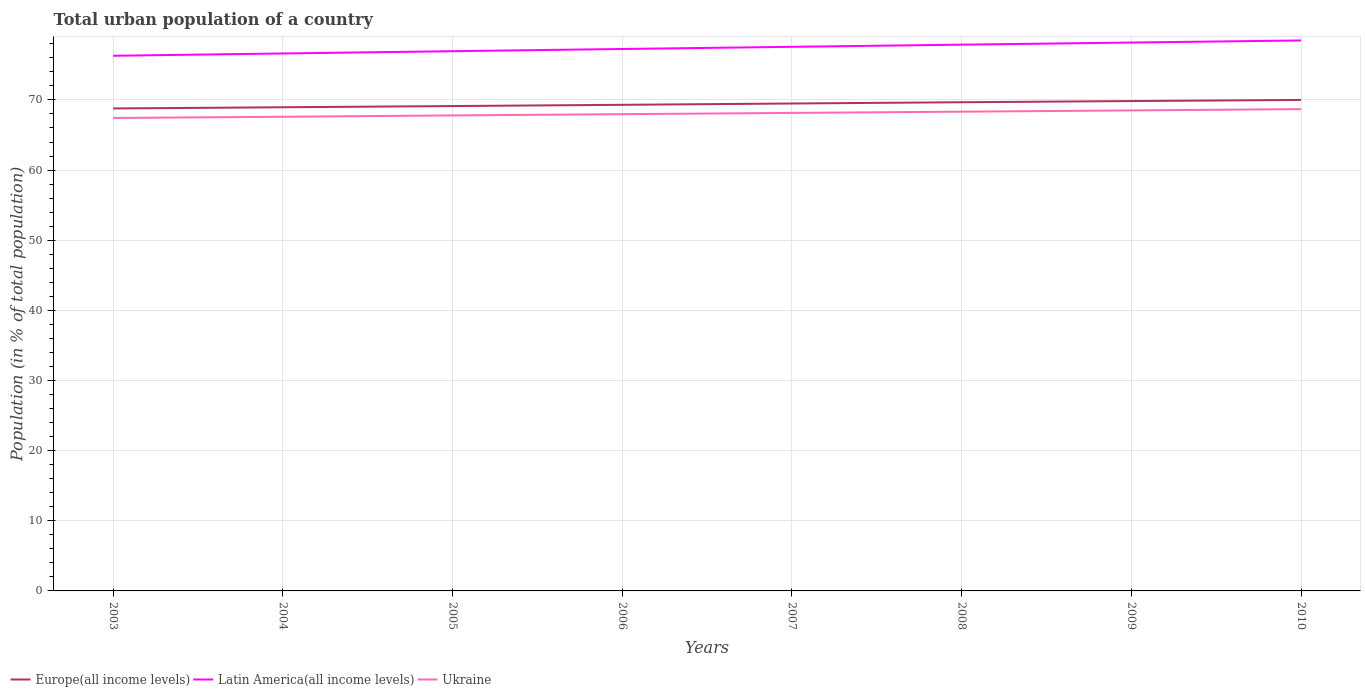Does the line corresponding to Ukraine intersect with the line corresponding to Latin America(all income levels)?
Keep it short and to the point. No. Across all years, what is the maximum urban population in Latin America(all income levels)?
Offer a terse response. 76.3. What is the total urban population in Ukraine in the graph?
Offer a terse response. -0.36. What is the difference between the highest and the second highest urban population in Ukraine?
Give a very brief answer. 1.26. What is the difference between the highest and the lowest urban population in Ukraine?
Your answer should be compact. 4. How many lines are there?
Your answer should be compact. 3. What is the difference between two consecutive major ticks on the Y-axis?
Ensure brevity in your answer.  10. Are the values on the major ticks of Y-axis written in scientific E-notation?
Your response must be concise. No. Does the graph contain any zero values?
Offer a very short reply. No. How are the legend labels stacked?
Your response must be concise. Horizontal. What is the title of the graph?
Make the answer very short. Total urban population of a country. Does "Virgin Islands" appear as one of the legend labels in the graph?
Give a very brief answer. No. What is the label or title of the X-axis?
Offer a terse response. Years. What is the label or title of the Y-axis?
Offer a very short reply. Population (in % of total population). What is the Population (in % of total population) of Europe(all income levels) in 2003?
Your response must be concise. 68.78. What is the Population (in % of total population) in Latin America(all income levels) in 2003?
Keep it short and to the point. 76.3. What is the Population (in % of total population) in Ukraine in 2003?
Make the answer very short. 67.43. What is the Population (in % of total population) in Europe(all income levels) in 2004?
Offer a very short reply. 68.95. What is the Population (in % of total population) of Latin America(all income levels) in 2004?
Provide a succinct answer. 76.62. What is the Population (in % of total population) of Ukraine in 2004?
Your answer should be very brief. 67.6. What is the Population (in % of total population) in Europe(all income levels) in 2005?
Offer a very short reply. 69.12. What is the Population (in % of total population) of Latin America(all income levels) in 2005?
Provide a short and direct response. 76.94. What is the Population (in % of total population) of Ukraine in 2005?
Provide a succinct answer. 67.79. What is the Population (in % of total population) in Europe(all income levels) in 2006?
Give a very brief answer. 69.3. What is the Population (in % of total population) in Latin America(all income levels) in 2006?
Offer a terse response. 77.26. What is the Population (in % of total population) in Ukraine in 2006?
Your response must be concise. 67.97. What is the Population (in % of total population) of Europe(all income levels) in 2007?
Provide a short and direct response. 69.49. What is the Population (in % of total population) in Latin America(all income levels) in 2007?
Offer a terse response. 77.57. What is the Population (in % of total population) in Ukraine in 2007?
Offer a terse response. 68.15. What is the Population (in % of total population) in Europe(all income levels) in 2008?
Ensure brevity in your answer.  69.67. What is the Population (in % of total population) in Latin America(all income levels) in 2008?
Provide a succinct answer. 77.88. What is the Population (in % of total population) in Ukraine in 2008?
Provide a succinct answer. 68.33. What is the Population (in % of total population) of Europe(all income levels) in 2009?
Your answer should be compact. 69.84. What is the Population (in % of total population) of Latin America(all income levels) in 2009?
Offer a very short reply. 78.18. What is the Population (in % of total population) in Ukraine in 2009?
Ensure brevity in your answer.  68.5. What is the Population (in % of total population) of Europe(all income levels) in 2010?
Give a very brief answer. 70. What is the Population (in % of total population) of Latin America(all income levels) in 2010?
Ensure brevity in your answer.  78.48. What is the Population (in % of total population) of Ukraine in 2010?
Your answer should be very brief. 68.69. Across all years, what is the maximum Population (in % of total population) of Europe(all income levels)?
Offer a terse response. 70. Across all years, what is the maximum Population (in % of total population) of Latin America(all income levels)?
Make the answer very short. 78.48. Across all years, what is the maximum Population (in % of total population) of Ukraine?
Ensure brevity in your answer.  68.69. Across all years, what is the minimum Population (in % of total population) of Europe(all income levels)?
Keep it short and to the point. 68.78. Across all years, what is the minimum Population (in % of total population) of Latin America(all income levels)?
Keep it short and to the point. 76.3. Across all years, what is the minimum Population (in % of total population) in Ukraine?
Offer a terse response. 67.43. What is the total Population (in % of total population) in Europe(all income levels) in the graph?
Ensure brevity in your answer.  555.16. What is the total Population (in % of total population) in Latin America(all income levels) in the graph?
Your answer should be very brief. 619.23. What is the total Population (in % of total population) in Ukraine in the graph?
Ensure brevity in your answer.  544.44. What is the difference between the Population (in % of total population) of Europe(all income levels) in 2003 and that in 2004?
Make the answer very short. -0.17. What is the difference between the Population (in % of total population) in Latin America(all income levels) in 2003 and that in 2004?
Provide a succinct answer. -0.33. What is the difference between the Population (in % of total population) in Ukraine in 2003 and that in 2004?
Offer a terse response. -0.17. What is the difference between the Population (in % of total population) of Europe(all income levels) in 2003 and that in 2005?
Offer a terse response. -0.34. What is the difference between the Population (in % of total population) of Latin America(all income levels) in 2003 and that in 2005?
Provide a succinct answer. -0.65. What is the difference between the Population (in % of total population) in Ukraine in 2003 and that in 2005?
Your response must be concise. -0.36. What is the difference between the Population (in % of total population) in Europe(all income levels) in 2003 and that in 2006?
Give a very brief answer. -0.52. What is the difference between the Population (in % of total population) of Latin America(all income levels) in 2003 and that in 2006?
Offer a very short reply. -0.96. What is the difference between the Population (in % of total population) of Ukraine in 2003 and that in 2006?
Give a very brief answer. -0.54. What is the difference between the Population (in % of total population) in Europe(all income levels) in 2003 and that in 2007?
Offer a very short reply. -0.71. What is the difference between the Population (in % of total population) in Latin America(all income levels) in 2003 and that in 2007?
Ensure brevity in your answer.  -1.28. What is the difference between the Population (in % of total population) in Ukraine in 2003 and that in 2007?
Offer a very short reply. -0.72. What is the difference between the Population (in % of total population) in Europe(all income levels) in 2003 and that in 2008?
Keep it short and to the point. -0.89. What is the difference between the Population (in % of total population) in Latin America(all income levels) in 2003 and that in 2008?
Offer a terse response. -1.58. What is the difference between the Population (in % of total population) of Ukraine in 2003 and that in 2008?
Provide a short and direct response. -0.9. What is the difference between the Population (in % of total population) in Europe(all income levels) in 2003 and that in 2009?
Offer a very short reply. -1.05. What is the difference between the Population (in % of total population) in Latin America(all income levels) in 2003 and that in 2009?
Offer a terse response. -1.88. What is the difference between the Population (in % of total population) of Ukraine in 2003 and that in 2009?
Give a very brief answer. -1.07. What is the difference between the Population (in % of total population) in Europe(all income levels) in 2003 and that in 2010?
Offer a very short reply. -1.21. What is the difference between the Population (in % of total population) of Latin America(all income levels) in 2003 and that in 2010?
Offer a very short reply. -2.18. What is the difference between the Population (in % of total population) of Ukraine in 2003 and that in 2010?
Make the answer very short. -1.26. What is the difference between the Population (in % of total population) in Europe(all income levels) in 2004 and that in 2005?
Your response must be concise. -0.17. What is the difference between the Population (in % of total population) of Latin America(all income levels) in 2004 and that in 2005?
Provide a succinct answer. -0.32. What is the difference between the Population (in % of total population) in Ukraine in 2004 and that in 2005?
Provide a short and direct response. -0.19. What is the difference between the Population (in % of total population) of Europe(all income levels) in 2004 and that in 2006?
Make the answer very short. -0.35. What is the difference between the Population (in % of total population) of Latin America(all income levels) in 2004 and that in 2006?
Provide a short and direct response. -0.64. What is the difference between the Population (in % of total population) in Ukraine in 2004 and that in 2006?
Offer a very short reply. -0.37. What is the difference between the Population (in % of total population) in Europe(all income levels) in 2004 and that in 2007?
Provide a succinct answer. -0.54. What is the difference between the Population (in % of total population) in Latin America(all income levels) in 2004 and that in 2007?
Your answer should be compact. -0.95. What is the difference between the Population (in % of total population) of Ukraine in 2004 and that in 2007?
Make the answer very short. -0.55. What is the difference between the Population (in % of total population) in Europe(all income levels) in 2004 and that in 2008?
Make the answer very short. -0.72. What is the difference between the Population (in % of total population) in Latin America(all income levels) in 2004 and that in 2008?
Your answer should be very brief. -1.26. What is the difference between the Population (in % of total population) of Ukraine in 2004 and that in 2008?
Ensure brevity in your answer.  -0.73. What is the difference between the Population (in % of total population) of Europe(all income levels) in 2004 and that in 2009?
Keep it short and to the point. -0.89. What is the difference between the Population (in % of total population) of Latin America(all income levels) in 2004 and that in 2009?
Provide a short and direct response. -1.56. What is the difference between the Population (in % of total population) of Ukraine in 2004 and that in 2009?
Offer a terse response. -0.91. What is the difference between the Population (in % of total population) in Europe(all income levels) in 2004 and that in 2010?
Provide a short and direct response. -1.04. What is the difference between the Population (in % of total population) of Latin America(all income levels) in 2004 and that in 2010?
Keep it short and to the point. -1.85. What is the difference between the Population (in % of total population) in Ukraine in 2004 and that in 2010?
Offer a terse response. -1.09. What is the difference between the Population (in % of total population) of Europe(all income levels) in 2005 and that in 2006?
Make the answer very short. -0.18. What is the difference between the Population (in % of total population) in Latin America(all income levels) in 2005 and that in 2006?
Your answer should be compact. -0.32. What is the difference between the Population (in % of total population) in Ukraine in 2005 and that in 2006?
Offer a very short reply. -0.18. What is the difference between the Population (in % of total population) of Europe(all income levels) in 2005 and that in 2007?
Keep it short and to the point. -0.36. What is the difference between the Population (in % of total population) in Latin America(all income levels) in 2005 and that in 2007?
Your response must be concise. -0.63. What is the difference between the Population (in % of total population) in Ukraine in 2005 and that in 2007?
Your answer should be very brief. -0.36. What is the difference between the Population (in % of total population) of Europe(all income levels) in 2005 and that in 2008?
Provide a short and direct response. -0.55. What is the difference between the Population (in % of total population) in Latin America(all income levels) in 2005 and that in 2008?
Ensure brevity in your answer.  -0.93. What is the difference between the Population (in % of total population) in Ukraine in 2005 and that in 2008?
Ensure brevity in your answer.  -0.54. What is the difference between the Population (in % of total population) in Europe(all income levels) in 2005 and that in 2009?
Give a very brief answer. -0.71. What is the difference between the Population (in % of total population) of Latin America(all income levels) in 2005 and that in 2009?
Offer a terse response. -1.24. What is the difference between the Population (in % of total population) in Ukraine in 2005 and that in 2009?
Provide a succinct answer. -0.71. What is the difference between the Population (in % of total population) of Europe(all income levels) in 2005 and that in 2010?
Your response must be concise. -0.87. What is the difference between the Population (in % of total population) of Latin America(all income levels) in 2005 and that in 2010?
Keep it short and to the point. -1.53. What is the difference between the Population (in % of total population) in Ukraine in 2005 and that in 2010?
Offer a very short reply. -0.9. What is the difference between the Population (in % of total population) in Europe(all income levels) in 2006 and that in 2007?
Keep it short and to the point. -0.19. What is the difference between the Population (in % of total population) in Latin America(all income levels) in 2006 and that in 2007?
Offer a very short reply. -0.31. What is the difference between the Population (in % of total population) of Ukraine in 2006 and that in 2007?
Keep it short and to the point. -0.18. What is the difference between the Population (in % of total population) in Europe(all income levels) in 2006 and that in 2008?
Offer a terse response. -0.37. What is the difference between the Population (in % of total population) of Latin America(all income levels) in 2006 and that in 2008?
Provide a succinct answer. -0.62. What is the difference between the Population (in % of total population) in Ukraine in 2006 and that in 2008?
Your response must be concise. -0.36. What is the difference between the Population (in % of total population) in Europe(all income levels) in 2006 and that in 2009?
Ensure brevity in your answer.  -0.53. What is the difference between the Population (in % of total population) in Latin America(all income levels) in 2006 and that in 2009?
Provide a short and direct response. -0.92. What is the difference between the Population (in % of total population) in Ukraine in 2006 and that in 2009?
Offer a terse response. -0.53. What is the difference between the Population (in % of total population) of Europe(all income levels) in 2006 and that in 2010?
Keep it short and to the point. -0.69. What is the difference between the Population (in % of total population) in Latin America(all income levels) in 2006 and that in 2010?
Ensure brevity in your answer.  -1.22. What is the difference between the Population (in % of total population) in Ukraine in 2006 and that in 2010?
Provide a short and direct response. -0.72. What is the difference between the Population (in % of total population) of Europe(all income levels) in 2007 and that in 2008?
Provide a short and direct response. -0.18. What is the difference between the Population (in % of total population) of Latin America(all income levels) in 2007 and that in 2008?
Make the answer very short. -0.31. What is the difference between the Population (in % of total population) of Ukraine in 2007 and that in 2008?
Provide a short and direct response. -0.18. What is the difference between the Population (in % of total population) of Europe(all income levels) in 2007 and that in 2009?
Provide a short and direct response. -0.35. What is the difference between the Population (in % of total population) in Latin America(all income levels) in 2007 and that in 2009?
Your response must be concise. -0.61. What is the difference between the Population (in % of total population) of Ukraine in 2007 and that in 2009?
Offer a very short reply. -0.35. What is the difference between the Population (in % of total population) of Europe(all income levels) in 2007 and that in 2010?
Offer a very short reply. -0.51. What is the difference between the Population (in % of total population) in Latin America(all income levels) in 2007 and that in 2010?
Your response must be concise. -0.91. What is the difference between the Population (in % of total population) of Ukraine in 2007 and that in 2010?
Provide a short and direct response. -0.54. What is the difference between the Population (in % of total population) of Europe(all income levels) in 2008 and that in 2009?
Keep it short and to the point. -0.17. What is the difference between the Population (in % of total population) of Latin America(all income levels) in 2008 and that in 2009?
Keep it short and to the point. -0.3. What is the difference between the Population (in % of total population) in Ukraine in 2008 and that in 2009?
Your response must be concise. -0.18. What is the difference between the Population (in % of total population) in Europe(all income levels) in 2008 and that in 2010?
Offer a terse response. -0.33. What is the difference between the Population (in % of total population) of Latin America(all income levels) in 2008 and that in 2010?
Your answer should be very brief. -0.6. What is the difference between the Population (in % of total population) in Ukraine in 2008 and that in 2010?
Give a very brief answer. -0.36. What is the difference between the Population (in % of total population) of Europe(all income levels) in 2009 and that in 2010?
Ensure brevity in your answer.  -0.16. What is the difference between the Population (in % of total population) of Latin America(all income levels) in 2009 and that in 2010?
Give a very brief answer. -0.3. What is the difference between the Population (in % of total population) of Ukraine in 2009 and that in 2010?
Your answer should be compact. -0.18. What is the difference between the Population (in % of total population) of Europe(all income levels) in 2003 and the Population (in % of total population) of Latin America(all income levels) in 2004?
Offer a terse response. -7.84. What is the difference between the Population (in % of total population) in Europe(all income levels) in 2003 and the Population (in % of total population) in Ukraine in 2004?
Provide a short and direct response. 1.19. What is the difference between the Population (in % of total population) in Latin America(all income levels) in 2003 and the Population (in % of total population) in Ukraine in 2004?
Provide a succinct answer. 8.7. What is the difference between the Population (in % of total population) in Europe(all income levels) in 2003 and the Population (in % of total population) in Latin America(all income levels) in 2005?
Offer a terse response. -8.16. What is the difference between the Population (in % of total population) of Latin America(all income levels) in 2003 and the Population (in % of total population) of Ukraine in 2005?
Give a very brief answer. 8.51. What is the difference between the Population (in % of total population) of Europe(all income levels) in 2003 and the Population (in % of total population) of Latin America(all income levels) in 2006?
Provide a succinct answer. -8.48. What is the difference between the Population (in % of total population) in Europe(all income levels) in 2003 and the Population (in % of total population) in Ukraine in 2006?
Ensure brevity in your answer.  0.81. What is the difference between the Population (in % of total population) in Latin America(all income levels) in 2003 and the Population (in % of total population) in Ukraine in 2006?
Ensure brevity in your answer.  8.33. What is the difference between the Population (in % of total population) of Europe(all income levels) in 2003 and the Population (in % of total population) of Latin America(all income levels) in 2007?
Make the answer very short. -8.79. What is the difference between the Population (in % of total population) of Europe(all income levels) in 2003 and the Population (in % of total population) of Ukraine in 2007?
Your answer should be compact. 0.64. What is the difference between the Population (in % of total population) of Latin America(all income levels) in 2003 and the Population (in % of total population) of Ukraine in 2007?
Ensure brevity in your answer.  8.15. What is the difference between the Population (in % of total population) in Europe(all income levels) in 2003 and the Population (in % of total population) in Latin America(all income levels) in 2008?
Your answer should be very brief. -9.1. What is the difference between the Population (in % of total population) of Europe(all income levels) in 2003 and the Population (in % of total population) of Ukraine in 2008?
Your answer should be very brief. 0.46. What is the difference between the Population (in % of total population) of Latin America(all income levels) in 2003 and the Population (in % of total population) of Ukraine in 2008?
Provide a succinct answer. 7.97. What is the difference between the Population (in % of total population) of Europe(all income levels) in 2003 and the Population (in % of total population) of Latin America(all income levels) in 2009?
Provide a succinct answer. -9.4. What is the difference between the Population (in % of total population) in Europe(all income levels) in 2003 and the Population (in % of total population) in Ukraine in 2009?
Provide a succinct answer. 0.28. What is the difference between the Population (in % of total population) in Latin America(all income levels) in 2003 and the Population (in % of total population) in Ukraine in 2009?
Your answer should be compact. 7.79. What is the difference between the Population (in % of total population) of Europe(all income levels) in 2003 and the Population (in % of total population) of Latin America(all income levels) in 2010?
Provide a succinct answer. -9.7. What is the difference between the Population (in % of total population) in Europe(all income levels) in 2003 and the Population (in % of total population) in Ukraine in 2010?
Your response must be concise. 0.1. What is the difference between the Population (in % of total population) of Latin America(all income levels) in 2003 and the Population (in % of total population) of Ukraine in 2010?
Give a very brief answer. 7.61. What is the difference between the Population (in % of total population) of Europe(all income levels) in 2004 and the Population (in % of total population) of Latin America(all income levels) in 2005?
Your answer should be compact. -7.99. What is the difference between the Population (in % of total population) of Europe(all income levels) in 2004 and the Population (in % of total population) of Ukraine in 2005?
Provide a succinct answer. 1.16. What is the difference between the Population (in % of total population) of Latin America(all income levels) in 2004 and the Population (in % of total population) of Ukraine in 2005?
Your answer should be very brief. 8.83. What is the difference between the Population (in % of total population) of Europe(all income levels) in 2004 and the Population (in % of total population) of Latin America(all income levels) in 2006?
Provide a succinct answer. -8.31. What is the difference between the Population (in % of total population) in Europe(all income levels) in 2004 and the Population (in % of total population) in Ukraine in 2006?
Make the answer very short. 0.98. What is the difference between the Population (in % of total population) in Latin America(all income levels) in 2004 and the Population (in % of total population) in Ukraine in 2006?
Your answer should be compact. 8.65. What is the difference between the Population (in % of total population) in Europe(all income levels) in 2004 and the Population (in % of total population) in Latin America(all income levels) in 2007?
Provide a short and direct response. -8.62. What is the difference between the Population (in % of total population) of Europe(all income levels) in 2004 and the Population (in % of total population) of Ukraine in 2007?
Make the answer very short. 0.81. What is the difference between the Population (in % of total population) of Latin America(all income levels) in 2004 and the Population (in % of total population) of Ukraine in 2007?
Make the answer very short. 8.48. What is the difference between the Population (in % of total population) in Europe(all income levels) in 2004 and the Population (in % of total population) in Latin America(all income levels) in 2008?
Make the answer very short. -8.93. What is the difference between the Population (in % of total population) of Europe(all income levels) in 2004 and the Population (in % of total population) of Ukraine in 2008?
Your answer should be very brief. 0.63. What is the difference between the Population (in % of total population) in Latin America(all income levels) in 2004 and the Population (in % of total population) in Ukraine in 2008?
Your response must be concise. 8.3. What is the difference between the Population (in % of total population) in Europe(all income levels) in 2004 and the Population (in % of total population) in Latin America(all income levels) in 2009?
Give a very brief answer. -9.23. What is the difference between the Population (in % of total population) of Europe(all income levels) in 2004 and the Population (in % of total population) of Ukraine in 2009?
Your answer should be compact. 0.45. What is the difference between the Population (in % of total population) of Latin America(all income levels) in 2004 and the Population (in % of total population) of Ukraine in 2009?
Provide a short and direct response. 8.12. What is the difference between the Population (in % of total population) of Europe(all income levels) in 2004 and the Population (in % of total population) of Latin America(all income levels) in 2010?
Make the answer very short. -9.53. What is the difference between the Population (in % of total population) in Europe(all income levels) in 2004 and the Population (in % of total population) in Ukraine in 2010?
Make the answer very short. 0.27. What is the difference between the Population (in % of total population) of Latin America(all income levels) in 2004 and the Population (in % of total population) of Ukraine in 2010?
Your answer should be very brief. 7.94. What is the difference between the Population (in % of total population) in Europe(all income levels) in 2005 and the Population (in % of total population) in Latin America(all income levels) in 2006?
Make the answer very short. -8.14. What is the difference between the Population (in % of total population) of Europe(all income levels) in 2005 and the Population (in % of total population) of Ukraine in 2006?
Provide a short and direct response. 1.16. What is the difference between the Population (in % of total population) of Latin America(all income levels) in 2005 and the Population (in % of total population) of Ukraine in 2006?
Make the answer very short. 8.97. What is the difference between the Population (in % of total population) of Europe(all income levels) in 2005 and the Population (in % of total population) of Latin America(all income levels) in 2007?
Ensure brevity in your answer.  -8.45. What is the difference between the Population (in % of total population) in Europe(all income levels) in 2005 and the Population (in % of total population) in Ukraine in 2007?
Your answer should be compact. 0.98. What is the difference between the Population (in % of total population) of Latin America(all income levels) in 2005 and the Population (in % of total population) of Ukraine in 2007?
Offer a very short reply. 8.8. What is the difference between the Population (in % of total population) of Europe(all income levels) in 2005 and the Population (in % of total population) of Latin America(all income levels) in 2008?
Your response must be concise. -8.75. What is the difference between the Population (in % of total population) of Europe(all income levels) in 2005 and the Population (in % of total population) of Ukraine in 2008?
Keep it short and to the point. 0.8. What is the difference between the Population (in % of total population) of Latin America(all income levels) in 2005 and the Population (in % of total population) of Ukraine in 2008?
Provide a short and direct response. 8.62. What is the difference between the Population (in % of total population) in Europe(all income levels) in 2005 and the Population (in % of total population) in Latin America(all income levels) in 2009?
Provide a short and direct response. -9.06. What is the difference between the Population (in % of total population) of Europe(all income levels) in 2005 and the Population (in % of total population) of Ukraine in 2009?
Give a very brief answer. 0.62. What is the difference between the Population (in % of total population) in Latin America(all income levels) in 2005 and the Population (in % of total population) in Ukraine in 2009?
Your answer should be compact. 8.44. What is the difference between the Population (in % of total population) of Europe(all income levels) in 2005 and the Population (in % of total population) of Latin America(all income levels) in 2010?
Provide a succinct answer. -9.35. What is the difference between the Population (in % of total population) of Europe(all income levels) in 2005 and the Population (in % of total population) of Ukraine in 2010?
Provide a succinct answer. 0.44. What is the difference between the Population (in % of total population) in Latin America(all income levels) in 2005 and the Population (in % of total population) in Ukraine in 2010?
Your response must be concise. 8.26. What is the difference between the Population (in % of total population) of Europe(all income levels) in 2006 and the Population (in % of total population) of Latin America(all income levels) in 2007?
Provide a short and direct response. -8.27. What is the difference between the Population (in % of total population) of Europe(all income levels) in 2006 and the Population (in % of total population) of Ukraine in 2007?
Your response must be concise. 1.16. What is the difference between the Population (in % of total population) in Latin America(all income levels) in 2006 and the Population (in % of total population) in Ukraine in 2007?
Your answer should be compact. 9.11. What is the difference between the Population (in % of total population) of Europe(all income levels) in 2006 and the Population (in % of total population) of Latin America(all income levels) in 2008?
Your answer should be very brief. -8.58. What is the difference between the Population (in % of total population) in Europe(all income levels) in 2006 and the Population (in % of total population) in Ukraine in 2008?
Keep it short and to the point. 0.98. What is the difference between the Population (in % of total population) of Latin America(all income levels) in 2006 and the Population (in % of total population) of Ukraine in 2008?
Make the answer very short. 8.94. What is the difference between the Population (in % of total population) in Europe(all income levels) in 2006 and the Population (in % of total population) in Latin America(all income levels) in 2009?
Your response must be concise. -8.88. What is the difference between the Population (in % of total population) in Europe(all income levels) in 2006 and the Population (in % of total population) in Ukraine in 2009?
Ensure brevity in your answer.  0.8. What is the difference between the Population (in % of total population) of Latin America(all income levels) in 2006 and the Population (in % of total population) of Ukraine in 2009?
Give a very brief answer. 8.76. What is the difference between the Population (in % of total population) in Europe(all income levels) in 2006 and the Population (in % of total population) in Latin America(all income levels) in 2010?
Your answer should be very brief. -9.17. What is the difference between the Population (in % of total population) in Europe(all income levels) in 2006 and the Population (in % of total population) in Ukraine in 2010?
Offer a very short reply. 0.62. What is the difference between the Population (in % of total population) in Latin America(all income levels) in 2006 and the Population (in % of total population) in Ukraine in 2010?
Make the answer very short. 8.57. What is the difference between the Population (in % of total population) of Europe(all income levels) in 2007 and the Population (in % of total population) of Latin America(all income levels) in 2008?
Give a very brief answer. -8.39. What is the difference between the Population (in % of total population) of Europe(all income levels) in 2007 and the Population (in % of total population) of Ukraine in 2008?
Your answer should be compact. 1.16. What is the difference between the Population (in % of total population) in Latin America(all income levels) in 2007 and the Population (in % of total population) in Ukraine in 2008?
Make the answer very short. 9.25. What is the difference between the Population (in % of total population) in Europe(all income levels) in 2007 and the Population (in % of total population) in Latin America(all income levels) in 2009?
Make the answer very short. -8.69. What is the difference between the Population (in % of total population) of Europe(all income levels) in 2007 and the Population (in % of total population) of Ukraine in 2009?
Offer a terse response. 0.99. What is the difference between the Population (in % of total population) of Latin America(all income levels) in 2007 and the Population (in % of total population) of Ukraine in 2009?
Give a very brief answer. 9.07. What is the difference between the Population (in % of total population) of Europe(all income levels) in 2007 and the Population (in % of total population) of Latin America(all income levels) in 2010?
Keep it short and to the point. -8.99. What is the difference between the Population (in % of total population) in Europe(all income levels) in 2007 and the Population (in % of total population) in Ukraine in 2010?
Keep it short and to the point. 0.8. What is the difference between the Population (in % of total population) of Latin America(all income levels) in 2007 and the Population (in % of total population) of Ukraine in 2010?
Offer a terse response. 8.89. What is the difference between the Population (in % of total population) of Europe(all income levels) in 2008 and the Population (in % of total population) of Latin America(all income levels) in 2009?
Make the answer very short. -8.51. What is the difference between the Population (in % of total population) of Europe(all income levels) in 2008 and the Population (in % of total population) of Ukraine in 2009?
Provide a succinct answer. 1.17. What is the difference between the Population (in % of total population) of Latin America(all income levels) in 2008 and the Population (in % of total population) of Ukraine in 2009?
Provide a short and direct response. 9.38. What is the difference between the Population (in % of total population) in Europe(all income levels) in 2008 and the Population (in % of total population) in Latin America(all income levels) in 2010?
Your response must be concise. -8.81. What is the difference between the Population (in % of total population) of Europe(all income levels) in 2008 and the Population (in % of total population) of Ukraine in 2010?
Your response must be concise. 0.98. What is the difference between the Population (in % of total population) in Latin America(all income levels) in 2008 and the Population (in % of total population) in Ukraine in 2010?
Offer a very short reply. 9.19. What is the difference between the Population (in % of total population) in Europe(all income levels) in 2009 and the Population (in % of total population) in Latin America(all income levels) in 2010?
Ensure brevity in your answer.  -8.64. What is the difference between the Population (in % of total population) of Europe(all income levels) in 2009 and the Population (in % of total population) of Ukraine in 2010?
Keep it short and to the point. 1.15. What is the difference between the Population (in % of total population) of Latin America(all income levels) in 2009 and the Population (in % of total population) of Ukraine in 2010?
Your response must be concise. 9.49. What is the average Population (in % of total population) of Europe(all income levels) per year?
Make the answer very short. 69.39. What is the average Population (in % of total population) of Latin America(all income levels) per year?
Keep it short and to the point. 77.4. What is the average Population (in % of total population) in Ukraine per year?
Provide a succinct answer. 68.06. In the year 2003, what is the difference between the Population (in % of total population) of Europe(all income levels) and Population (in % of total population) of Latin America(all income levels)?
Provide a succinct answer. -7.51. In the year 2003, what is the difference between the Population (in % of total population) of Europe(all income levels) and Population (in % of total population) of Ukraine?
Make the answer very short. 1.36. In the year 2003, what is the difference between the Population (in % of total population) of Latin America(all income levels) and Population (in % of total population) of Ukraine?
Your response must be concise. 8.87. In the year 2004, what is the difference between the Population (in % of total population) of Europe(all income levels) and Population (in % of total population) of Latin America(all income levels)?
Make the answer very short. -7.67. In the year 2004, what is the difference between the Population (in % of total population) in Europe(all income levels) and Population (in % of total population) in Ukraine?
Provide a short and direct response. 1.36. In the year 2004, what is the difference between the Population (in % of total population) of Latin America(all income levels) and Population (in % of total population) of Ukraine?
Ensure brevity in your answer.  9.03. In the year 2005, what is the difference between the Population (in % of total population) in Europe(all income levels) and Population (in % of total population) in Latin America(all income levels)?
Your answer should be very brief. -7.82. In the year 2005, what is the difference between the Population (in % of total population) in Europe(all income levels) and Population (in % of total population) in Ukraine?
Provide a succinct answer. 1.33. In the year 2005, what is the difference between the Population (in % of total population) in Latin America(all income levels) and Population (in % of total population) in Ukraine?
Offer a very short reply. 9.15. In the year 2006, what is the difference between the Population (in % of total population) of Europe(all income levels) and Population (in % of total population) of Latin America(all income levels)?
Your answer should be compact. -7.96. In the year 2006, what is the difference between the Population (in % of total population) of Europe(all income levels) and Population (in % of total population) of Ukraine?
Provide a short and direct response. 1.33. In the year 2006, what is the difference between the Population (in % of total population) in Latin America(all income levels) and Population (in % of total population) in Ukraine?
Your answer should be compact. 9.29. In the year 2007, what is the difference between the Population (in % of total population) in Europe(all income levels) and Population (in % of total population) in Latin America(all income levels)?
Offer a very short reply. -8.08. In the year 2007, what is the difference between the Population (in % of total population) in Europe(all income levels) and Population (in % of total population) in Ukraine?
Ensure brevity in your answer.  1.34. In the year 2007, what is the difference between the Population (in % of total population) of Latin America(all income levels) and Population (in % of total population) of Ukraine?
Give a very brief answer. 9.42. In the year 2008, what is the difference between the Population (in % of total population) in Europe(all income levels) and Population (in % of total population) in Latin America(all income levels)?
Offer a terse response. -8.21. In the year 2008, what is the difference between the Population (in % of total population) of Europe(all income levels) and Population (in % of total population) of Ukraine?
Provide a succinct answer. 1.35. In the year 2008, what is the difference between the Population (in % of total population) of Latin America(all income levels) and Population (in % of total population) of Ukraine?
Provide a short and direct response. 9.55. In the year 2009, what is the difference between the Population (in % of total population) in Europe(all income levels) and Population (in % of total population) in Latin America(all income levels)?
Provide a succinct answer. -8.34. In the year 2009, what is the difference between the Population (in % of total population) in Europe(all income levels) and Population (in % of total population) in Ukraine?
Give a very brief answer. 1.34. In the year 2009, what is the difference between the Population (in % of total population) in Latin America(all income levels) and Population (in % of total population) in Ukraine?
Make the answer very short. 9.68. In the year 2010, what is the difference between the Population (in % of total population) in Europe(all income levels) and Population (in % of total population) in Latin America(all income levels)?
Make the answer very short. -8.48. In the year 2010, what is the difference between the Population (in % of total population) of Europe(all income levels) and Population (in % of total population) of Ukraine?
Provide a succinct answer. 1.31. In the year 2010, what is the difference between the Population (in % of total population) in Latin America(all income levels) and Population (in % of total population) in Ukraine?
Keep it short and to the point. 9.79. What is the ratio of the Population (in % of total population) in Europe(all income levels) in 2003 to that in 2004?
Offer a terse response. 1. What is the ratio of the Population (in % of total population) in Latin America(all income levels) in 2003 to that in 2004?
Keep it short and to the point. 1. What is the ratio of the Population (in % of total population) in Europe(all income levels) in 2003 to that in 2005?
Offer a very short reply. 1. What is the ratio of the Population (in % of total population) of Latin America(all income levels) in 2003 to that in 2005?
Offer a terse response. 0.99. What is the ratio of the Population (in % of total population) of Europe(all income levels) in 2003 to that in 2006?
Your response must be concise. 0.99. What is the ratio of the Population (in % of total population) in Latin America(all income levels) in 2003 to that in 2006?
Provide a short and direct response. 0.99. What is the ratio of the Population (in % of total population) in Europe(all income levels) in 2003 to that in 2007?
Offer a terse response. 0.99. What is the ratio of the Population (in % of total population) in Latin America(all income levels) in 2003 to that in 2007?
Give a very brief answer. 0.98. What is the ratio of the Population (in % of total population) in Ukraine in 2003 to that in 2007?
Your answer should be compact. 0.99. What is the ratio of the Population (in % of total population) in Europe(all income levels) in 2003 to that in 2008?
Make the answer very short. 0.99. What is the ratio of the Population (in % of total population) in Latin America(all income levels) in 2003 to that in 2008?
Give a very brief answer. 0.98. What is the ratio of the Population (in % of total population) of Ukraine in 2003 to that in 2008?
Your answer should be very brief. 0.99. What is the ratio of the Population (in % of total population) of Europe(all income levels) in 2003 to that in 2009?
Offer a terse response. 0.98. What is the ratio of the Population (in % of total population) of Latin America(all income levels) in 2003 to that in 2009?
Ensure brevity in your answer.  0.98. What is the ratio of the Population (in % of total population) of Ukraine in 2003 to that in 2009?
Make the answer very short. 0.98. What is the ratio of the Population (in % of total population) of Europe(all income levels) in 2003 to that in 2010?
Provide a short and direct response. 0.98. What is the ratio of the Population (in % of total population) of Latin America(all income levels) in 2003 to that in 2010?
Offer a terse response. 0.97. What is the ratio of the Population (in % of total population) in Ukraine in 2003 to that in 2010?
Give a very brief answer. 0.98. What is the ratio of the Population (in % of total population) in Europe(all income levels) in 2004 to that in 2005?
Provide a short and direct response. 1. What is the ratio of the Population (in % of total population) in Europe(all income levels) in 2004 to that in 2006?
Offer a terse response. 0.99. What is the ratio of the Population (in % of total population) in Europe(all income levels) in 2004 to that in 2007?
Offer a terse response. 0.99. What is the ratio of the Population (in % of total population) in Latin America(all income levels) in 2004 to that in 2008?
Keep it short and to the point. 0.98. What is the ratio of the Population (in % of total population) of Ukraine in 2004 to that in 2008?
Your answer should be very brief. 0.99. What is the ratio of the Population (in % of total population) in Europe(all income levels) in 2004 to that in 2009?
Your answer should be compact. 0.99. What is the ratio of the Population (in % of total population) of Latin America(all income levels) in 2004 to that in 2009?
Provide a short and direct response. 0.98. What is the ratio of the Population (in % of total population) of Ukraine in 2004 to that in 2009?
Your answer should be compact. 0.99. What is the ratio of the Population (in % of total population) of Europe(all income levels) in 2004 to that in 2010?
Keep it short and to the point. 0.99. What is the ratio of the Population (in % of total population) in Latin America(all income levels) in 2004 to that in 2010?
Make the answer very short. 0.98. What is the ratio of the Population (in % of total population) of Ukraine in 2004 to that in 2010?
Provide a short and direct response. 0.98. What is the ratio of the Population (in % of total population) in Europe(all income levels) in 2005 to that in 2006?
Your answer should be compact. 1. What is the ratio of the Population (in % of total population) of Ukraine in 2005 to that in 2006?
Ensure brevity in your answer.  1. What is the ratio of the Population (in % of total population) of Europe(all income levels) in 2005 to that in 2007?
Make the answer very short. 0.99. What is the ratio of the Population (in % of total population) in Latin America(all income levels) in 2005 to that in 2007?
Make the answer very short. 0.99. What is the ratio of the Population (in % of total population) in Europe(all income levels) in 2005 to that in 2008?
Provide a short and direct response. 0.99. What is the ratio of the Population (in % of total population) of Latin America(all income levels) in 2005 to that in 2009?
Give a very brief answer. 0.98. What is the ratio of the Population (in % of total population) of Europe(all income levels) in 2005 to that in 2010?
Offer a very short reply. 0.99. What is the ratio of the Population (in % of total population) of Latin America(all income levels) in 2005 to that in 2010?
Your answer should be very brief. 0.98. What is the ratio of the Population (in % of total population) of Ukraine in 2006 to that in 2007?
Ensure brevity in your answer.  1. What is the ratio of the Population (in % of total population) of Europe(all income levels) in 2006 to that in 2008?
Your answer should be compact. 0.99. What is the ratio of the Population (in % of total population) in Ukraine in 2006 to that in 2008?
Give a very brief answer. 0.99. What is the ratio of the Population (in % of total population) in Latin America(all income levels) in 2006 to that in 2009?
Offer a terse response. 0.99. What is the ratio of the Population (in % of total population) of Ukraine in 2006 to that in 2009?
Your response must be concise. 0.99. What is the ratio of the Population (in % of total population) in Europe(all income levels) in 2006 to that in 2010?
Keep it short and to the point. 0.99. What is the ratio of the Population (in % of total population) of Latin America(all income levels) in 2006 to that in 2010?
Provide a short and direct response. 0.98. What is the ratio of the Population (in % of total population) in Ukraine in 2006 to that in 2010?
Ensure brevity in your answer.  0.99. What is the ratio of the Population (in % of total population) of Europe(all income levels) in 2007 to that in 2009?
Provide a succinct answer. 0.99. What is the ratio of the Population (in % of total population) of Latin America(all income levels) in 2007 to that in 2009?
Your answer should be compact. 0.99. What is the ratio of the Population (in % of total population) of Ukraine in 2007 to that in 2009?
Keep it short and to the point. 0.99. What is the ratio of the Population (in % of total population) in Latin America(all income levels) in 2007 to that in 2010?
Offer a terse response. 0.99. What is the ratio of the Population (in % of total population) of Ukraine in 2007 to that in 2010?
Offer a terse response. 0.99. What is the ratio of the Population (in % of total population) of Europe(all income levels) in 2008 to that in 2009?
Make the answer very short. 1. What is the ratio of the Population (in % of total population) of Europe(all income levels) in 2008 to that in 2010?
Ensure brevity in your answer.  1. What is the ratio of the Population (in % of total population) of Latin America(all income levels) in 2008 to that in 2010?
Keep it short and to the point. 0.99. What is the ratio of the Population (in % of total population) in Latin America(all income levels) in 2009 to that in 2010?
Keep it short and to the point. 1. What is the difference between the highest and the second highest Population (in % of total population) of Europe(all income levels)?
Provide a succinct answer. 0.16. What is the difference between the highest and the second highest Population (in % of total population) in Latin America(all income levels)?
Give a very brief answer. 0.3. What is the difference between the highest and the second highest Population (in % of total population) of Ukraine?
Keep it short and to the point. 0.18. What is the difference between the highest and the lowest Population (in % of total population) of Europe(all income levels)?
Keep it short and to the point. 1.21. What is the difference between the highest and the lowest Population (in % of total population) of Latin America(all income levels)?
Your answer should be compact. 2.18. What is the difference between the highest and the lowest Population (in % of total population) of Ukraine?
Offer a terse response. 1.26. 